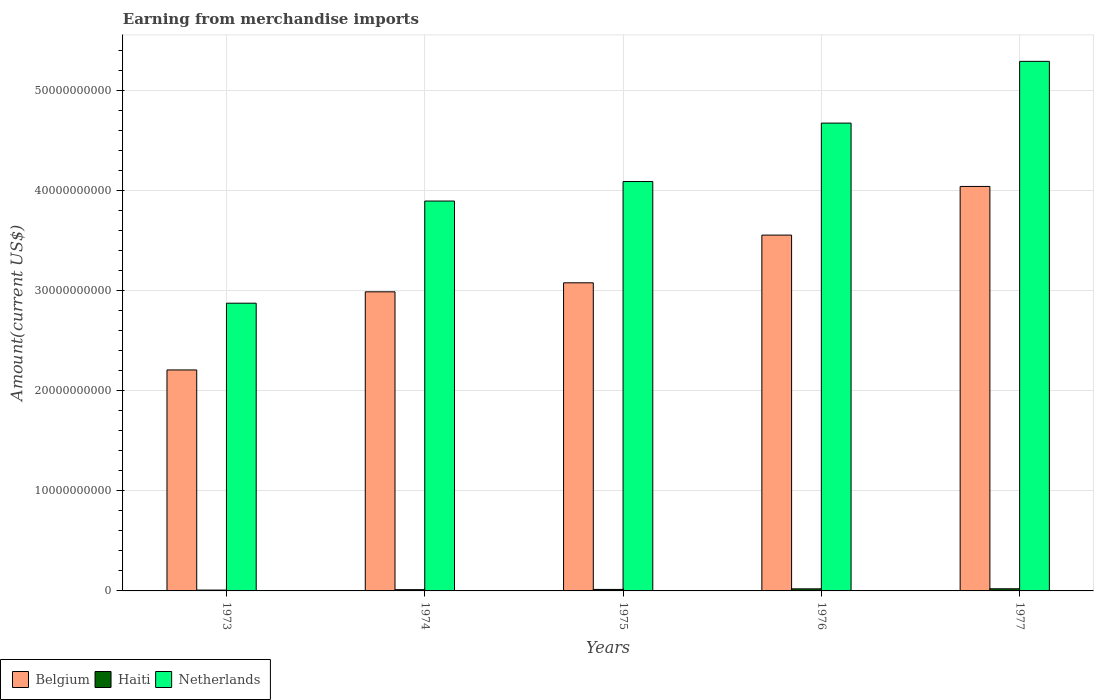How many different coloured bars are there?
Provide a short and direct response. 3. How many groups of bars are there?
Offer a very short reply. 5. How many bars are there on the 5th tick from the left?
Provide a succinct answer. 3. How many bars are there on the 5th tick from the right?
Provide a succinct answer. 3. What is the amount earned from merchandise imports in Belgium in 1976?
Your answer should be compact. 3.55e+1. Across all years, what is the maximum amount earned from merchandise imports in Haiti?
Ensure brevity in your answer.  2.13e+08. Across all years, what is the minimum amount earned from merchandise imports in Belgium?
Offer a terse response. 2.21e+1. In which year was the amount earned from merchandise imports in Netherlands maximum?
Your answer should be very brief. 1977. What is the total amount earned from merchandise imports in Netherlands in the graph?
Your answer should be very brief. 2.08e+11. What is the difference between the amount earned from merchandise imports in Haiti in 1974 and that in 1976?
Provide a succinct answer. -8.15e+07. What is the difference between the amount earned from merchandise imports in Belgium in 1976 and the amount earned from merchandise imports in Haiti in 1974?
Your answer should be compact. 3.54e+1. What is the average amount earned from merchandise imports in Netherlands per year?
Ensure brevity in your answer.  4.16e+1. In the year 1974, what is the difference between the amount earned from merchandise imports in Haiti and amount earned from merchandise imports in Netherlands?
Provide a short and direct response. -3.88e+1. What is the ratio of the amount earned from merchandise imports in Belgium in 1973 to that in 1974?
Offer a terse response. 0.74. Is the amount earned from merchandise imports in Netherlands in 1975 less than that in 1976?
Offer a very short reply. Yes. What is the difference between the highest and the second highest amount earned from merchandise imports in Netherlands?
Offer a terse response. 6.17e+09. What is the difference between the highest and the lowest amount earned from merchandise imports in Netherlands?
Provide a short and direct response. 2.42e+1. What does the 3rd bar from the left in 1974 represents?
Offer a very short reply. Netherlands. What is the difference between two consecutive major ticks on the Y-axis?
Your response must be concise. 1.00e+1. Does the graph contain grids?
Give a very brief answer. Yes. Where does the legend appear in the graph?
Provide a succinct answer. Bottom left. How many legend labels are there?
Your answer should be compact. 3. How are the legend labels stacked?
Provide a succinct answer. Horizontal. What is the title of the graph?
Keep it short and to the point. Earning from merchandise imports. Does "Zimbabwe" appear as one of the legend labels in the graph?
Give a very brief answer. No. What is the label or title of the X-axis?
Offer a very short reply. Years. What is the label or title of the Y-axis?
Your answer should be compact. Amount(current US$). What is the Amount(current US$) of Belgium in 1973?
Your response must be concise. 2.21e+1. What is the Amount(current US$) of Haiti in 1973?
Your answer should be compact. 8.32e+07. What is the Amount(current US$) in Netherlands in 1973?
Ensure brevity in your answer.  2.87e+1. What is the Amount(current US$) in Belgium in 1974?
Your answer should be compact. 2.99e+1. What is the Amount(current US$) in Haiti in 1974?
Give a very brief answer. 1.25e+08. What is the Amount(current US$) of Netherlands in 1974?
Your response must be concise. 3.89e+1. What is the Amount(current US$) of Belgium in 1975?
Offer a very short reply. 3.08e+1. What is the Amount(current US$) of Haiti in 1975?
Your answer should be very brief. 1.49e+08. What is the Amount(current US$) of Netherlands in 1975?
Offer a terse response. 4.09e+1. What is the Amount(current US$) of Belgium in 1976?
Your response must be concise. 3.55e+1. What is the Amount(current US$) of Haiti in 1976?
Give a very brief answer. 2.07e+08. What is the Amount(current US$) of Netherlands in 1976?
Make the answer very short. 4.67e+1. What is the Amount(current US$) in Belgium in 1977?
Provide a succinct answer. 4.04e+1. What is the Amount(current US$) in Haiti in 1977?
Offer a terse response. 2.13e+08. What is the Amount(current US$) in Netherlands in 1977?
Ensure brevity in your answer.  5.29e+1. Across all years, what is the maximum Amount(current US$) of Belgium?
Give a very brief answer. 4.04e+1. Across all years, what is the maximum Amount(current US$) in Haiti?
Your answer should be very brief. 2.13e+08. Across all years, what is the maximum Amount(current US$) of Netherlands?
Provide a short and direct response. 5.29e+1. Across all years, what is the minimum Amount(current US$) of Belgium?
Keep it short and to the point. 2.21e+1. Across all years, what is the minimum Amount(current US$) in Haiti?
Keep it short and to the point. 8.32e+07. Across all years, what is the minimum Amount(current US$) in Netherlands?
Your answer should be very brief. 2.87e+1. What is the total Amount(current US$) of Belgium in the graph?
Offer a very short reply. 1.59e+11. What is the total Amount(current US$) in Haiti in the graph?
Ensure brevity in your answer.  7.77e+08. What is the total Amount(current US$) in Netherlands in the graph?
Provide a short and direct response. 2.08e+11. What is the difference between the Amount(current US$) in Belgium in 1973 and that in 1974?
Ensure brevity in your answer.  -7.80e+09. What is the difference between the Amount(current US$) of Haiti in 1973 and that in 1974?
Provide a succinct answer. -4.21e+07. What is the difference between the Amount(current US$) of Netherlands in 1973 and that in 1974?
Ensure brevity in your answer.  -1.02e+1. What is the difference between the Amount(current US$) in Belgium in 1973 and that in 1975?
Provide a succinct answer. -8.71e+09. What is the difference between the Amount(current US$) in Haiti in 1973 and that in 1975?
Offer a terse response. -6.58e+07. What is the difference between the Amount(current US$) in Netherlands in 1973 and that in 1975?
Offer a terse response. -1.22e+1. What is the difference between the Amount(current US$) of Belgium in 1973 and that in 1976?
Make the answer very short. -1.35e+1. What is the difference between the Amount(current US$) in Haiti in 1973 and that in 1976?
Keep it short and to the point. -1.24e+08. What is the difference between the Amount(current US$) of Netherlands in 1973 and that in 1976?
Give a very brief answer. -1.80e+1. What is the difference between the Amount(current US$) in Belgium in 1973 and that in 1977?
Offer a very short reply. -1.83e+1. What is the difference between the Amount(current US$) of Haiti in 1973 and that in 1977?
Make the answer very short. -1.29e+08. What is the difference between the Amount(current US$) of Netherlands in 1973 and that in 1977?
Offer a very short reply. -2.42e+1. What is the difference between the Amount(current US$) of Belgium in 1974 and that in 1975?
Ensure brevity in your answer.  -9.01e+08. What is the difference between the Amount(current US$) in Haiti in 1974 and that in 1975?
Provide a succinct answer. -2.37e+07. What is the difference between the Amount(current US$) of Netherlands in 1974 and that in 1975?
Your answer should be compact. -1.95e+09. What is the difference between the Amount(current US$) of Belgium in 1974 and that in 1976?
Your answer should be very brief. -5.66e+09. What is the difference between the Amount(current US$) of Haiti in 1974 and that in 1976?
Your answer should be compact. -8.15e+07. What is the difference between the Amount(current US$) of Netherlands in 1974 and that in 1976?
Your answer should be compact. -7.79e+09. What is the difference between the Amount(current US$) of Belgium in 1974 and that in 1977?
Provide a short and direct response. -1.05e+1. What is the difference between the Amount(current US$) of Haiti in 1974 and that in 1977?
Your answer should be very brief. -8.74e+07. What is the difference between the Amount(current US$) in Netherlands in 1974 and that in 1977?
Ensure brevity in your answer.  -1.40e+1. What is the difference between the Amount(current US$) in Belgium in 1975 and that in 1976?
Provide a succinct answer. -4.76e+09. What is the difference between the Amount(current US$) of Haiti in 1975 and that in 1976?
Your response must be concise. -5.78e+07. What is the difference between the Amount(current US$) of Netherlands in 1975 and that in 1976?
Keep it short and to the point. -5.84e+09. What is the difference between the Amount(current US$) of Belgium in 1975 and that in 1977?
Ensure brevity in your answer.  -9.62e+09. What is the difference between the Amount(current US$) of Haiti in 1975 and that in 1977?
Provide a succinct answer. -6.37e+07. What is the difference between the Amount(current US$) in Netherlands in 1975 and that in 1977?
Give a very brief answer. -1.20e+1. What is the difference between the Amount(current US$) in Belgium in 1976 and that in 1977?
Give a very brief answer. -4.86e+09. What is the difference between the Amount(current US$) in Haiti in 1976 and that in 1977?
Give a very brief answer. -5.96e+06. What is the difference between the Amount(current US$) of Netherlands in 1976 and that in 1977?
Make the answer very short. -6.17e+09. What is the difference between the Amount(current US$) in Belgium in 1973 and the Amount(current US$) in Haiti in 1974?
Provide a short and direct response. 2.19e+1. What is the difference between the Amount(current US$) in Belgium in 1973 and the Amount(current US$) in Netherlands in 1974?
Provide a succinct answer. -1.69e+1. What is the difference between the Amount(current US$) in Haiti in 1973 and the Amount(current US$) in Netherlands in 1974?
Make the answer very short. -3.89e+1. What is the difference between the Amount(current US$) of Belgium in 1973 and the Amount(current US$) of Haiti in 1975?
Your response must be concise. 2.19e+1. What is the difference between the Amount(current US$) of Belgium in 1973 and the Amount(current US$) of Netherlands in 1975?
Give a very brief answer. -1.88e+1. What is the difference between the Amount(current US$) in Haiti in 1973 and the Amount(current US$) in Netherlands in 1975?
Your answer should be compact. -4.08e+1. What is the difference between the Amount(current US$) in Belgium in 1973 and the Amount(current US$) in Haiti in 1976?
Provide a short and direct response. 2.19e+1. What is the difference between the Amount(current US$) of Belgium in 1973 and the Amount(current US$) of Netherlands in 1976?
Ensure brevity in your answer.  -2.47e+1. What is the difference between the Amount(current US$) in Haiti in 1973 and the Amount(current US$) in Netherlands in 1976?
Ensure brevity in your answer.  -4.67e+1. What is the difference between the Amount(current US$) in Belgium in 1973 and the Amount(current US$) in Haiti in 1977?
Give a very brief answer. 2.19e+1. What is the difference between the Amount(current US$) in Belgium in 1973 and the Amount(current US$) in Netherlands in 1977?
Your answer should be very brief. -3.08e+1. What is the difference between the Amount(current US$) of Haiti in 1973 and the Amount(current US$) of Netherlands in 1977?
Make the answer very short. -5.28e+1. What is the difference between the Amount(current US$) of Belgium in 1974 and the Amount(current US$) of Haiti in 1975?
Your response must be concise. 2.97e+1. What is the difference between the Amount(current US$) in Belgium in 1974 and the Amount(current US$) in Netherlands in 1975?
Your answer should be compact. -1.10e+1. What is the difference between the Amount(current US$) in Haiti in 1974 and the Amount(current US$) in Netherlands in 1975?
Provide a succinct answer. -4.08e+1. What is the difference between the Amount(current US$) in Belgium in 1974 and the Amount(current US$) in Haiti in 1976?
Give a very brief answer. 2.97e+1. What is the difference between the Amount(current US$) of Belgium in 1974 and the Amount(current US$) of Netherlands in 1976?
Provide a short and direct response. -1.69e+1. What is the difference between the Amount(current US$) in Haiti in 1974 and the Amount(current US$) in Netherlands in 1976?
Give a very brief answer. -4.66e+1. What is the difference between the Amount(current US$) of Belgium in 1974 and the Amount(current US$) of Haiti in 1977?
Your response must be concise. 2.97e+1. What is the difference between the Amount(current US$) of Belgium in 1974 and the Amount(current US$) of Netherlands in 1977?
Offer a very short reply. -2.30e+1. What is the difference between the Amount(current US$) of Haiti in 1974 and the Amount(current US$) of Netherlands in 1977?
Ensure brevity in your answer.  -5.28e+1. What is the difference between the Amount(current US$) in Belgium in 1975 and the Amount(current US$) in Haiti in 1976?
Keep it short and to the point. 3.06e+1. What is the difference between the Amount(current US$) of Belgium in 1975 and the Amount(current US$) of Netherlands in 1976?
Offer a terse response. -1.60e+1. What is the difference between the Amount(current US$) in Haiti in 1975 and the Amount(current US$) in Netherlands in 1976?
Provide a succinct answer. -4.66e+1. What is the difference between the Amount(current US$) of Belgium in 1975 and the Amount(current US$) of Haiti in 1977?
Ensure brevity in your answer.  3.06e+1. What is the difference between the Amount(current US$) in Belgium in 1975 and the Amount(current US$) in Netherlands in 1977?
Offer a terse response. -2.21e+1. What is the difference between the Amount(current US$) in Haiti in 1975 and the Amount(current US$) in Netherlands in 1977?
Provide a succinct answer. -5.28e+1. What is the difference between the Amount(current US$) in Belgium in 1976 and the Amount(current US$) in Haiti in 1977?
Give a very brief answer. 3.53e+1. What is the difference between the Amount(current US$) of Belgium in 1976 and the Amount(current US$) of Netherlands in 1977?
Give a very brief answer. -1.74e+1. What is the difference between the Amount(current US$) of Haiti in 1976 and the Amount(current US$) of Netherlands in 1977?
Provide a short and direct response. -5.27e+1. What is the average Amount(current US$) of Belgium per year?
Make the answer very short. 3.17e+1. What is the average Amount(current US$) in Haiti per year?
Provide a succinct answer. 1.55e+08. What is the average Amount(current US$) of Netherlands per year?
Provide a short and direct response. 4.16e+1. In the year 1973, what is the difference between the Amount(current US$) in Belgium and Amount(current US$) in Haiti?
Your response must be concise. 2.20e+1. In the year 1973, what is the difference between the Amount(current US$) of Belgium and Amount(current US$) of Netherlands?
Offer a very short reply. -6.67e+09. In the year 1973, what is the difference between the Amount(current US$) in Haiti and Amount(current US$) in Netherlands?
Provide a succinct answer. -2.87e+1. In the year 1974, what is the difference between the Amount(current US$) of Belgium and Amount(current US$) of Haiti?
Your answer should be very brief. 2.98e+1. In the year 1974, what is the difference between the Amount(current US$) of Belgium and Amount(current US$) of Netherlands?
Offer a terse response. -9.07e+09. In the year 1974, what is the difference between the Amount(current US$) in Haiti and Amount(current US$) in Netherlands?
Your response must be concise. -3.88e+1. In the year 1975, what is the difference between the Amount(current US$) in Belgium and Amount(current US$) in Haiti?
Your response must be concise. 3.06e+1. In the year 1975, what is the difference between the Amount(current US$) in Belgium and Amount(current US$) in Netherlands?
Keep it short and to the point. -1.01e+1. In the year 1975, what is the difference between the Amount(current US$) in Haiti and Amount(current US$) in Netherlands?
Provide a short and direct response. -4.07e+1. In the year 1976, what is the difference between the Amount(current US$) of Belgium and Amount(current US$) of Haiti?
Provide a succinct answer. 3.53e+1. In the year 1976, what is the difference between the Amount(current US$) of Belgium and Amount(current US$) of Netherlands?
Your answer should be compact. -1.12e+1. In the year 1976, what is the difference between the Amount(current US$) of Haiti and Amount(current US$) of Netherlands?
Offer a terse response. -4.65e+1. In the year 1977, what is the difference between the Amount(current US$) in Belgium and Amount(current US$) in Haiti?
Provide a short and direct response. 4.02e+1. In the year 1977, what is the difference between the Amount(current US$) of Belgium and Amount(current US$) of Netherlands?
Make the answer very short. -1.25e+1. In the year 1977, what is the difference between the Amount(current US$) of Haiti and Amount(current US$) of Netherlands?
Keep it short and to the point. -5.27e+1. What is the ratio of the Amount(current US$) of Belgium in 1973 to that in 1974?
Provide a succinct answer. 0.74. What is the ratio of the Amount(current US$) of Haiti in 1973 to that in 1974?
Keep it short and to the point. 0.66. What is the ratio of the Amount(current US$) in Netherlands in 1973 to that in 1974?
Your response must be concise. 0.74. What is the ratio of the Amount(current US$) of Belgium in 1973 to that in 1975?
Your response must be concise. 0.72. What is the ratio of the Amount(current US$) in Haiti in 1973 to that in 1975?
Your response must be concise. 0.56. What is the ratio of the Amount(current US$) of Netherlands in 1973 to that in 1975?
Your response must be concise. 0.7. What is the ratio of the Amount(current US$) in Belgium in 1973 to that in 1976?
Provide a short and direct response. 0.62. What is the ratio of the Amount(current US$) of Haiti in 1973 to that in 1976?
Offer a very short reply. 0.4. What is the ratio of the Amount(current US$) in Netherlands in 1973 to that in 1976?
Make the answer very short. 0.61. What is the ratio of the Amount(current US$) in Belgium in 1973 to that in 1977?
Your answer should be compact. 0.55. What is the ratio of the Amount(current US$) in Haiti in 1973 to that in 1977?
Your answer should be compact. 0.39. What is the ratio of the Amount(current US$) of Netherlands in 1973 to that in 1977?
Keep it short and to the point. 0.54. What is the ratio of the Amount(current US$) of Belgium in 1974 to that in 1975?
Provide a succinct answer. 0.97. What is the ratio of the Amount(current US$) in Haiti in 1974 to that in 1975?
Provide a succinct answer. 0.84. What is the ratio of the Amount(current US$) in Netherlands in 1974 to that in 1975?
Keep it short and to the point. 0.95. What is the ratio of the Amount(current US$) in Belgium in 1974 to that in 1976?
Offer a very short reply. 0.84. What is the ratio of the Amount(current US$) of Haiti in 1974 to that in 1976?
Ensure brevity in your answer.  0.61. What is the ratio of the Amount(current US$) of Netherlands in 1974 to that in 1976?
Provide a succinct answer. 0.83. What is the ratio of the Amount(current US$) of Belgium in 1974 to that in 1977?
Offer a terse response. 0.74. What is the ratio of the Amount(current US$) in Haiti in 1974 to that in 1977?
Provide a succinct answer. 0.59. What is the ratio of the Amount(current US$) of Netherlands in 1974 to that in 1977?
Provide a short and direct response. 0.74. What is the ratio of the Amount(current US$) in Belgium in 1975 to that in 1976?
Keep it short and to the point. 0.87. What is the ratio of the Amount(current US$) in Haiti in 1975 to that in 1976?
Your response must be concise. 0.72. What is the ratio of the Amount(current US$) in Netherlands in 1975 to that in 1976?
Provide a succinct answer. 0.88. What is the ratio of the Amount(current US$) of Belgium in 1975 to that in 1977?
Ensure brevity in your answer.  0.76. What is the ratio of the Amount(current US$) of Haiti in 1975 to that in 1977?
Provide a succinct answer. 0.7. What is the ratio of the Amount(current US$) in Netherlands in 1975 to that in 1977?
Offer a terse response. 0.77. What is the ratio of the Amount(current US$) in Belgium in 1976 to that in 1977?
Make the answer very short. 0.88. What is the ratio of the Amount(current US$) of Haiti in 1976 to that in 1977?
Ensure brevity in your answer.  0.97. What is the ratio of the Amount(current US$) of Netherlands in 1976 to that in 1977?
Keep it short and to the point. 0.88. What is the difference between the highest and the second highest Amount(current US$) in Belgium?
Your answer should be compact. 4.86e+09. What is the difference between the highest and the second highest Amount(current US$) in Haiti?
Offer a very short reply. 5.96e+06. What is the difference between the highest and the second highest Amount(current US$) in Netherlands?
Make the answer very short. 6.17e+09. What is the difference between the highest and the lowest Amount(current US$) of Belgium?
Give a very brief answer. 1.83e+1. What is the difference between the highest and the lowest Amount(current US$) of Haiti?
Ensure brevity in your answer.  1.29e+08. What is the difference between the highest and the lowest Amount(current US$) of Netherlands?
Offer a terse response. 2.42e+1. 